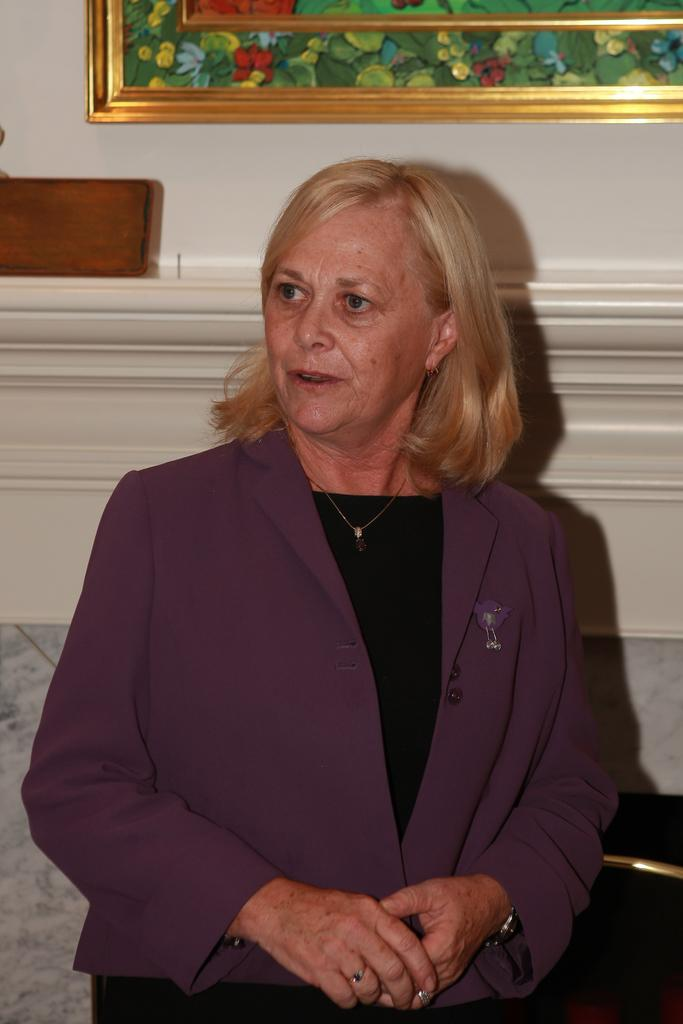Who is present in the image? There is a woman in the image. What is the woman doing in the image? The woman is seated. What can be seen on the wall behind the woman? There is a frame on the wall behind the woman. What type of ear is visible on the woman's head in the image? There is no ear visible on the woman's head in the image. What invention can be seen in the woman's hand in the image? There is no invention visible in the woman's hand in the image. 